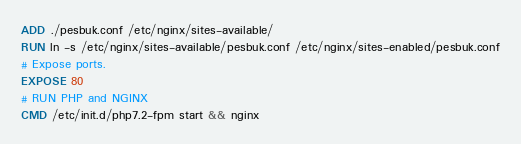Convert code to text. <code><loc_0><loc_0><loc_500><loc_500><_Dockerfile_>ADD ./pesbuk.conf /etc/nginx/sites-available/
RUN ln -s /etc/nginx/sites-available/pesbuk.conf /etc/nginx/sites-enabled/pesbuk.conf
# Expose ports.
EXPOSE 80
# RUN PHP and NGINX
CMD /etc/init.d/php7.2-fpm start && nginx
</code> 